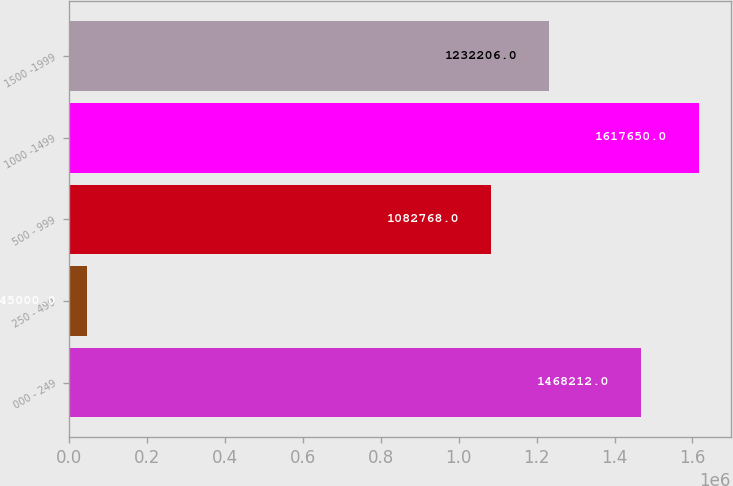Convert chart to OTSL. <chart><loc_0><loc_0><loc_500><loc_500><bar_chart><fcel>000 - 249<fcel>250 - 499<fcel>500 - 999<fcel>1000 -1499<fcel>1500 -1999<nl><fcel>1.46821e+06<fcel>45000<fcel>1.08277e+06<fcel>1.61765e+06<fcel>1.23221e+06<nl></chart> 